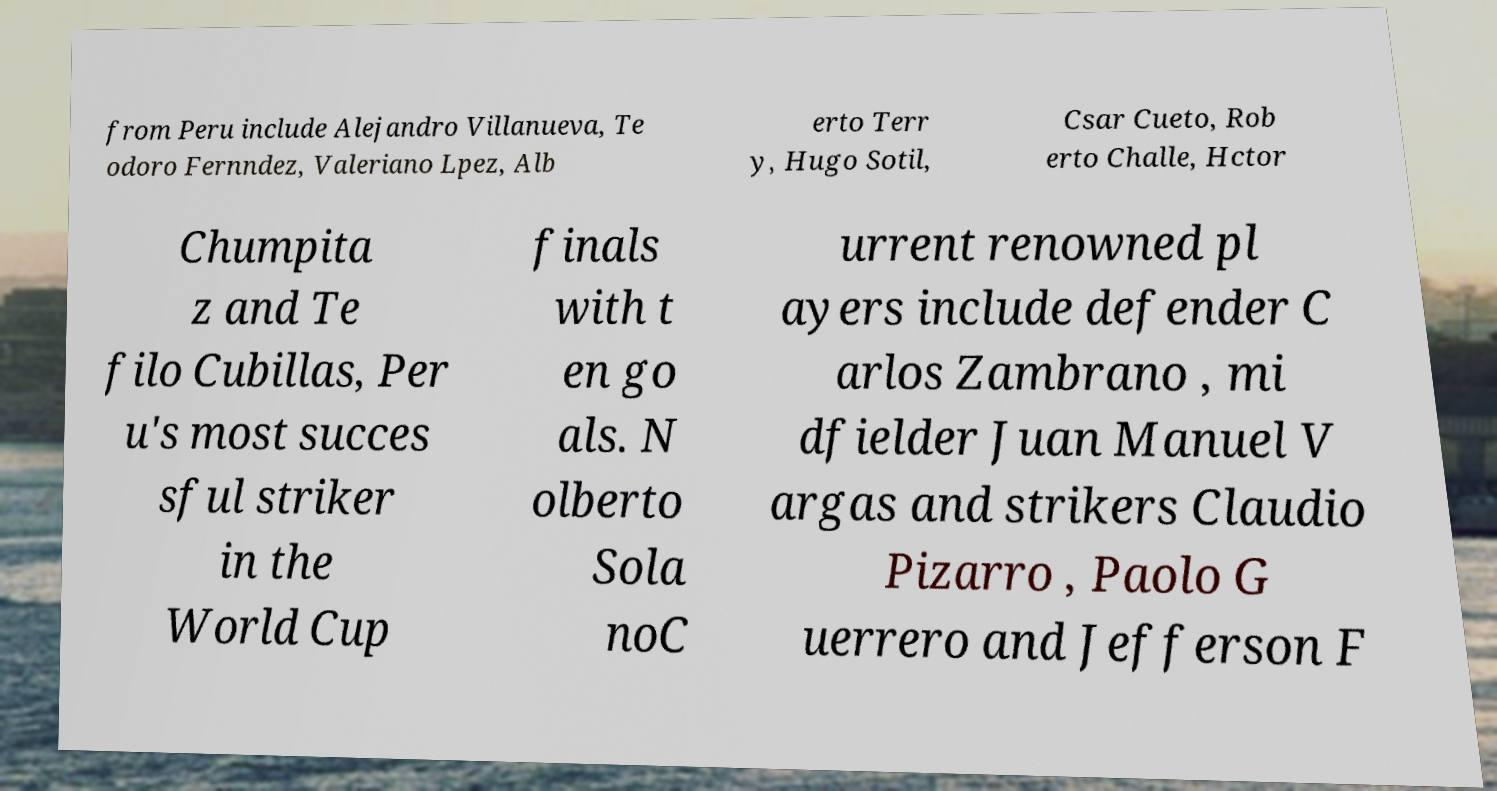Could you extract and type out the text from this image? from Peru include Alejandro Villanueva, Te odoro Fernndez, Valeriano Lpez, Alb erto Terr y, Hugo Sotil, Csar Cueto, Rob erto Challe, Hctor Chumpita z and Te filo Cubillas, Per u's most succes sful striker in the World Cup finals with t en go als. N olberto Sola noC urrent renowned pl ayers include defender C arlos Zambrano , mi dfielder Juan Manuel V argas and strikers Claudio Pizarro , Paolo G uerrero and Jefferson F 